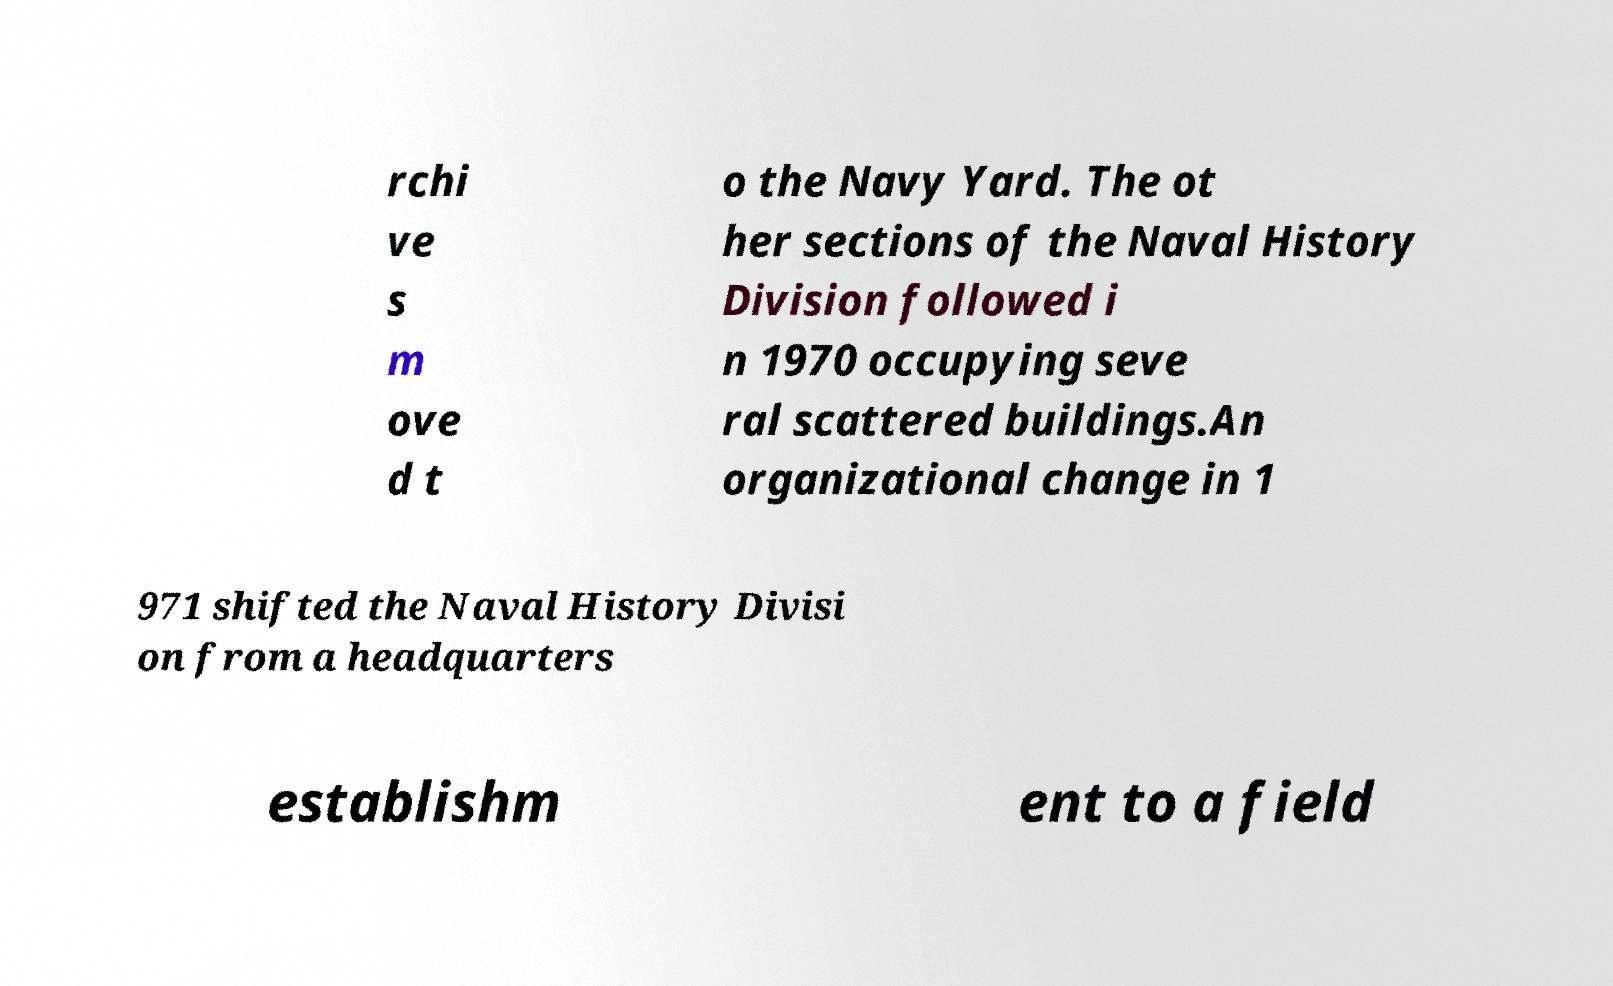Please identify and transcribe the text found in this image. rchi ve s m ove d t o the Navy Yard. The ot her sections of the Naval History Division followed i n 1970 occupying seve ral scattered buildings.An organizational change in 1 971 shifted the Naval History Divisi on from a headquarters establishm ent to a field 